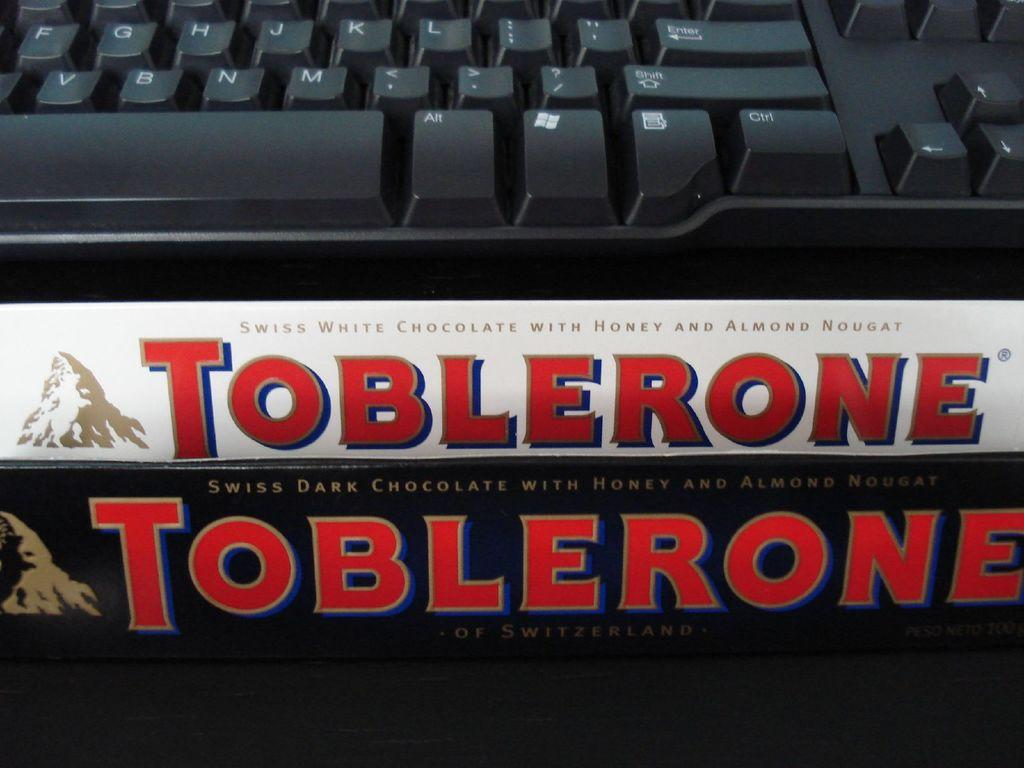<image>
Write a terse but informative summary of the picture. In front of the keyboard there is a white chocolate bar from Toblerone. 